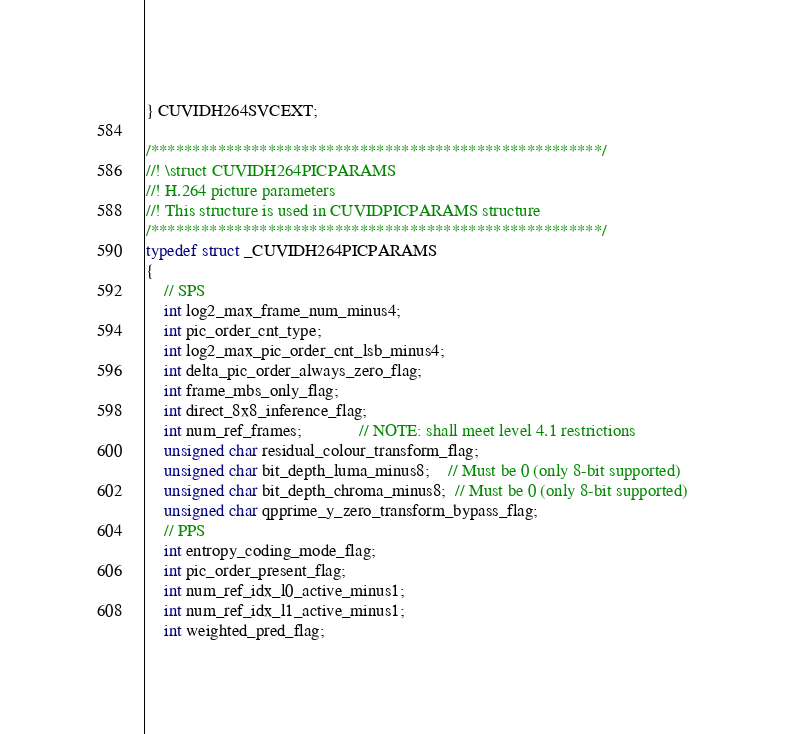<code> <loc_0><loc_0><loc_500><loc_500><_C_>} CUVIDH264SVCEXT;

/******************************************************/
//! \struct CUVIDH264PICPARAMS
//! H.264 picture parameters
//! This structure is used in CUVIDPICPARAMS structure
/******************************************************/
typedef struct _CUVIDH264PICPARAMS
{
    // SPS
    int log2_max_frame_num_minus4;
    int pic_order_cnt_type;
    int log2_max_pic_order_cnt_lsb_minus4;
    int delta_pic_order_always_zero_flag;
    int frame_mbs_only_flag;
    int direct_8x8_inference_flag;
    int num_ref_frames;             // NOTE: shall meet level 4.1 restrictions
    unsigned char residual_colour_transform_flag;
    unsigned char bit_depth_luma_minus8;    // Must be 0 (only 8-bit supported)
    unsigned char bit_depth_chroma_minus8;  // Must be 0 (only 8-bit supported)
    unsigned char qpprime_y_zero_transform_bypass_flag;
    // PPS
    int entropy_coding_mode_flag;
    int pic_order_present_flag;
    int num_ref_idx_l0_active_minus1;
    int num_ref_idx_l1_active_minus1;
    int weighted_pred_flag;</code> 